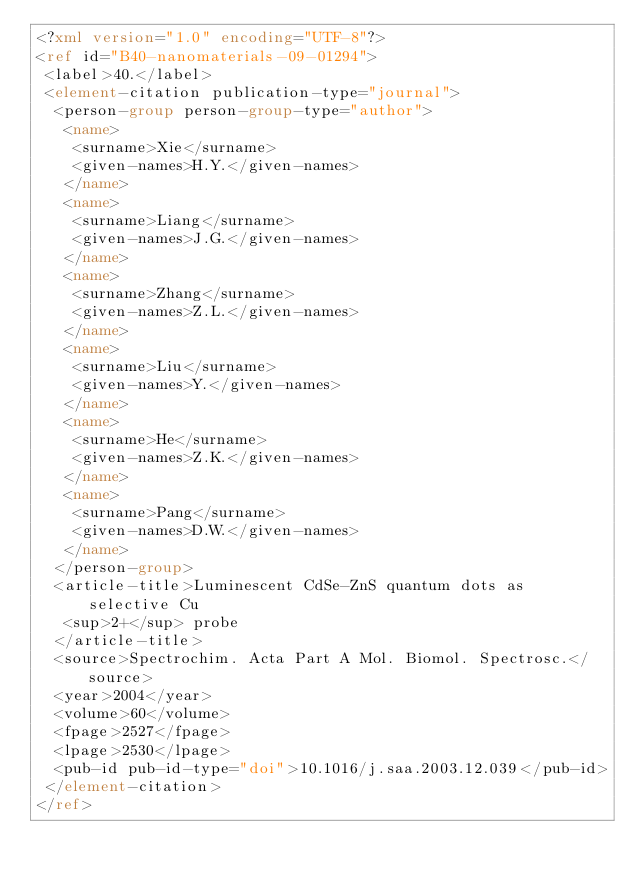<code> <loc_0><loc_0><loc_500><loc_500><_XML_><?xml version="1.0" encoding="UTF-8"?>
<ref id="B40-nanomaterials-09-01294">
 <label>40.</label>
 <element-citation publication-type="journal">
  <person-group person-group-type="author">
   <name>
    <surname>Xie</surname>
    <given-names>H.Y.</given-names>
   </name>
   <name>
    <surname>Liang</surname>
    <given-names>J.G.</given-names>
   </name>
   <name>
    <surname>Zhang</surname>
    <given-names>Z.L.</given-names>
   </name>
   <name>
    <surname>Liu</surname>
    <given-names>Y.</given-names>
   </name>
   <name>
    <surname>He</surname>
    <given-names>Z.K.</given-names>
   </name>
   <name>
    <surname>Pang</surname>
    <given-names>D.W.</given-names>
   </name>
  </person-group>
  <article-title>Luminescent CdSe-ZnS quantum dots as selective Cu
   <sup>2+</sup> probe
  </article-title>
  <source>Spectrochim. Acta Part A Mol. Biomol. Spectrosc.</source>
  <year>2004</year>
  <volume>60</volume>
  <fpage>2527</fpage>
  <lpage>2530</lpage>
  <pub-id pub-id-type="doi">10.1016/j.saa.2003.12.039</pub-id>
 </element-citation>
</ref>
</code> 